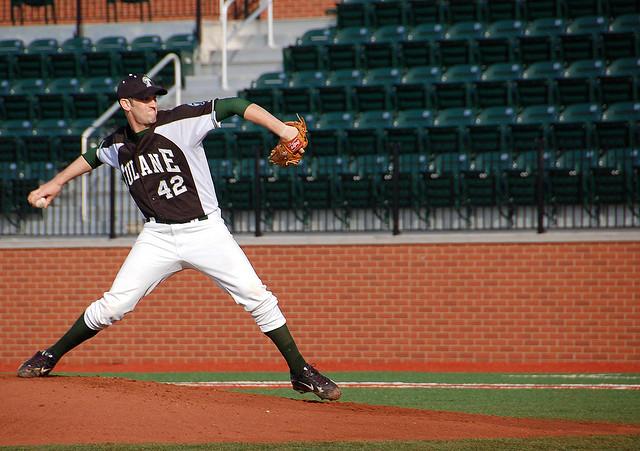Is this a recent image?
Answer briefly. Yes. Is the guy excited?
Write a very short answer. No. What emotion does the pitcher have on his face?
Answer briefly. Anger. What color is the man's belt?
Write a very short answer. Black. What sport is this?
Short answer required. Baseball. 